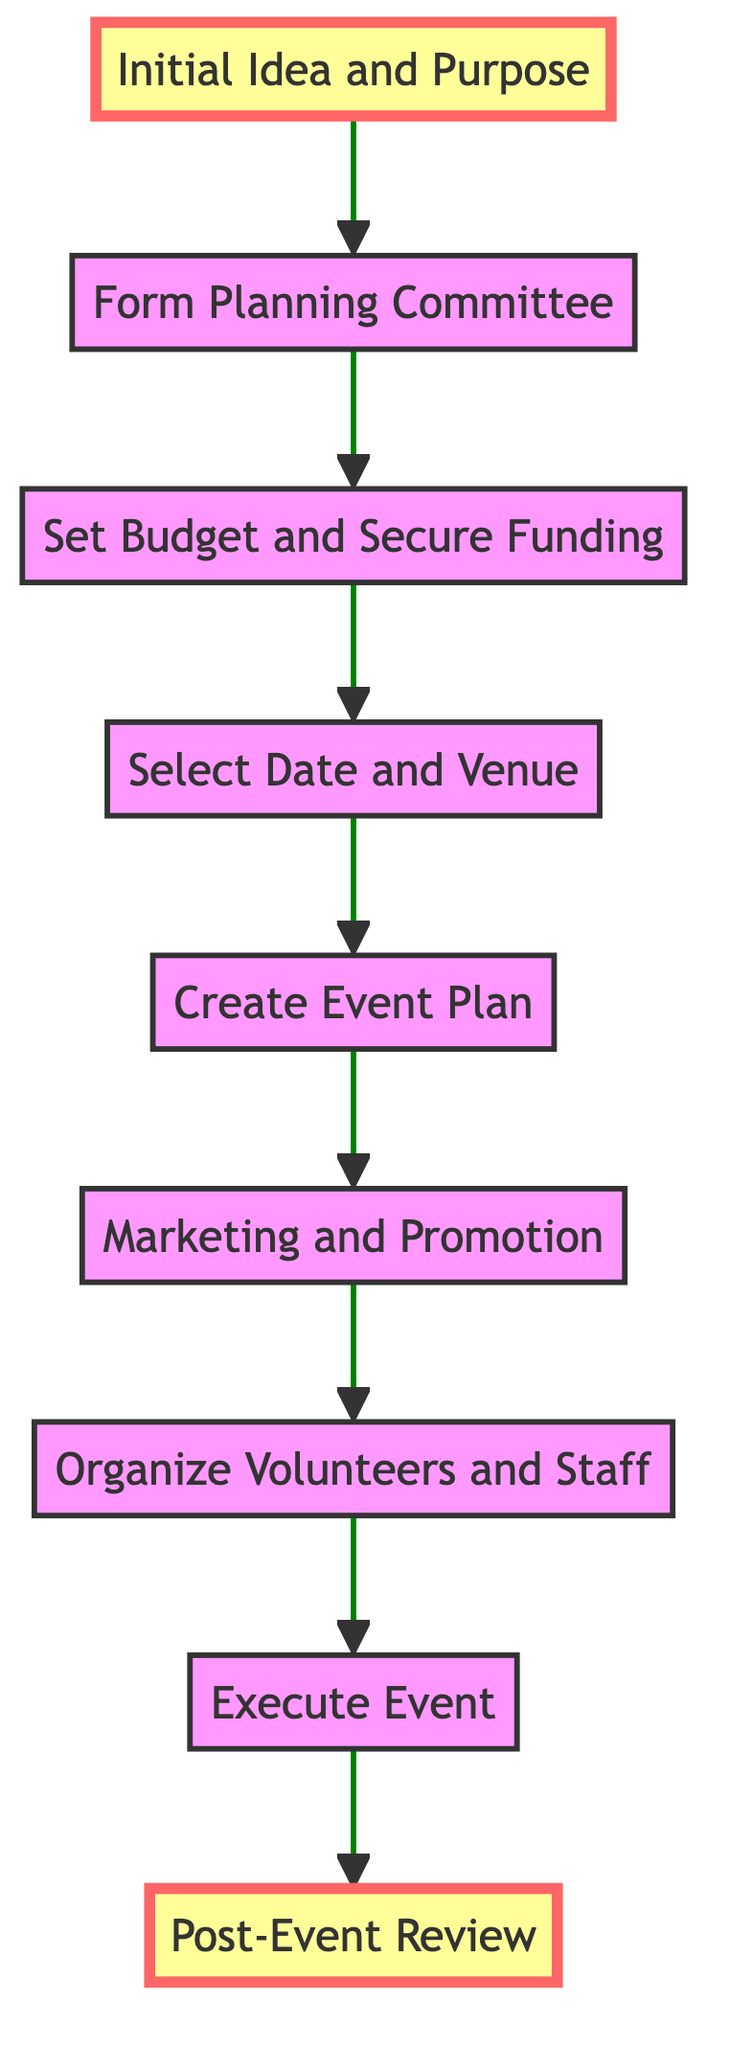What is the first step in organizing a community event? The first step is "Initial Idea and Purpose," which is the starting point where the purpose and objectives of the event are defined.
Answer: Initial Idea and Purpose How many steps are there in the flowchart? By counting the nodes in the flowchart, there are a total of nine steps that outline the process of organizing a community event.
Answer: 9 What follows the "Set Budget and Secure Funding" step? The node that comes directly after "Set Budget and Secure Funding" in the flowchart is "Select Date and Venue," indicating the next step in the process.
Answer: Select Date and Venue What is the last step of the process? The last step of the flowchart is "Post-Event Review," which involves collecting feedback and reviewing the event's successes and areas for improvement.
Answer: Post-Event Review Which step involves training volunteers? The step titled "Organize Volunteers and Staff" specifically mentions recruiting and training volunteers to assist with the event, making it the relevant step for this query.
Answer: Organize Volunteers and Staff What is the relationship between "Marketing and Promotion" and "Execute Event"? "Marketing and Promotion" is positioned directly before "Execute Event," indicating that marketing efforts are completed prior to executing the event itself.
Answer: Marketing and Promotion Which step is highlighted in the diagram? Both "Initial Idea and Purpose" and "Post-Event Review" are highlighted in the diagram, indicating they are significant focal points in the flow.
Answer: Initial Idea and Purpose, Post-Event Review Which step focuses on creating a detailed schedule? The step entitled "Create Event Plan" focuses on detailing the event schedule, activities, resources needed, and logistics for a successful event.
Answer: Create Event Plan What precedes the "Form Planning Committee" step? The step that comes before "Form Planning Committee" in the diagram is "Initial Idea and Purpose," where the initial brainstorming occurs.
Answer: Initial Idea and Purpose 